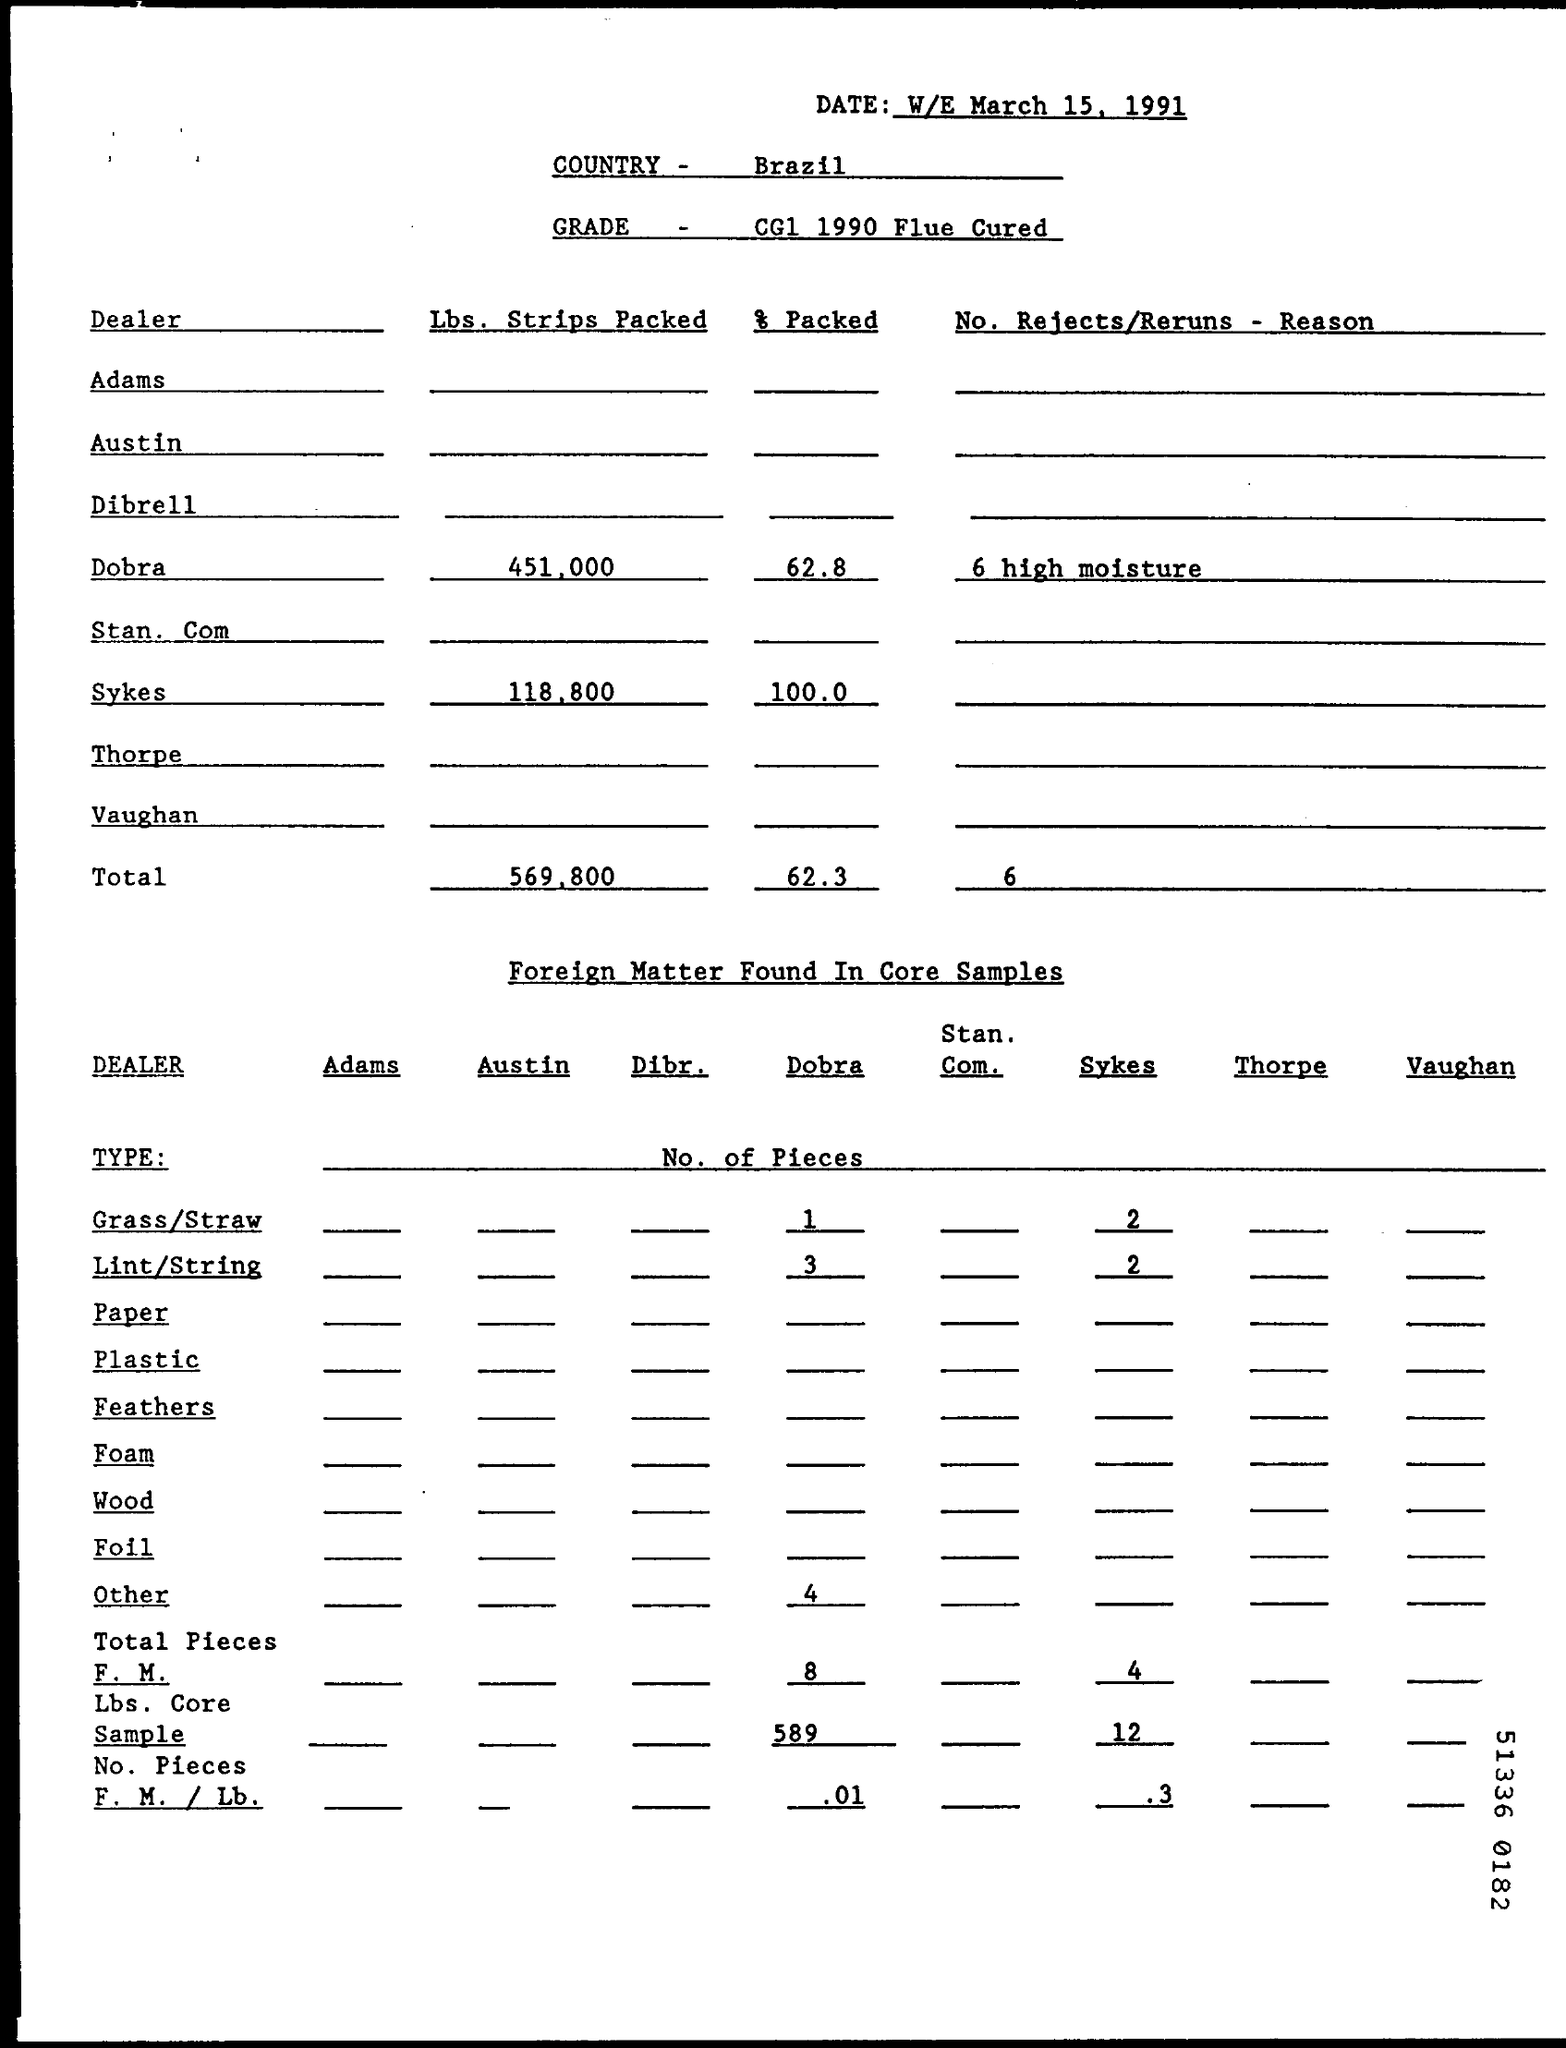What is the Total Lbs. Strips Packed? The total quantity of strips packed is 569,800 pounds. This figure represents the accumulation of the amounts listed under 'Lbs. Strips Packed' for various dealers, with Dobra contributing the most at 451,000 pounds and Sykes the least at 118,800 pounds, as indicated in the report dated week ending March 15, 1991, for Brazil's CG1 1990 Flue Cured tobacco. 